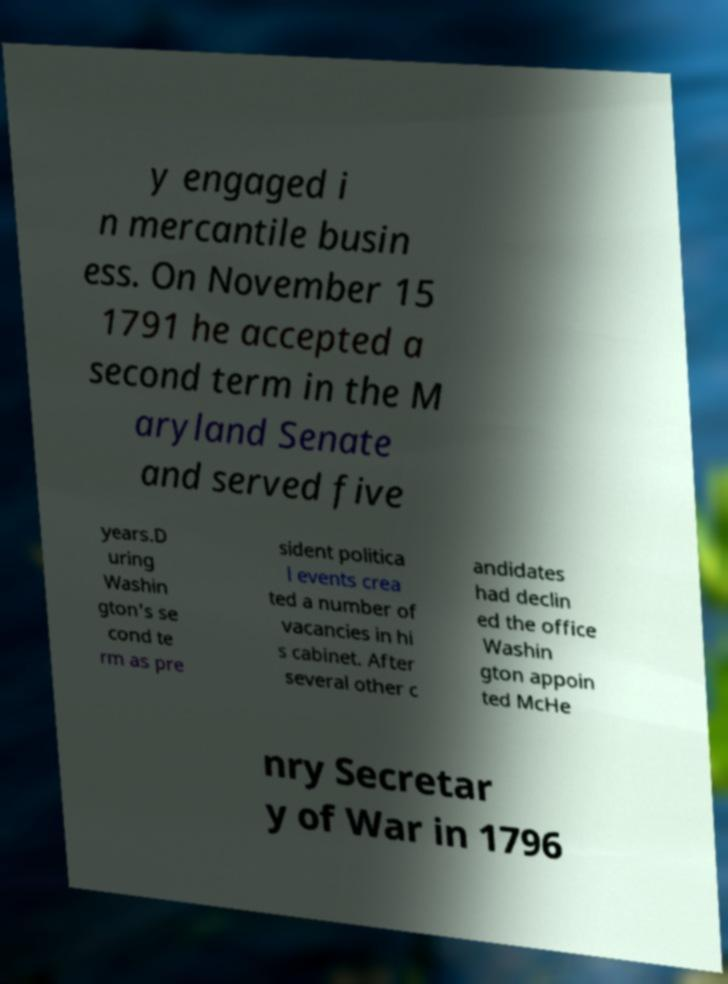Can you read and provide the text displayed in the image?This photo seems to have some interesting text. Can you extract and type it out for me? y engaged i n mercantile busin ess. On November 15 1791 he accepted a second term in the M aryland Senate and served five years.D uring Washin gton's se cond te rm as pre sident politica l events crea ted a number of vacancies in hi s cabinet. After several other c andidates had declin ed the office Washin gton appoin ted McHe nry Secretar y of War in 1796 